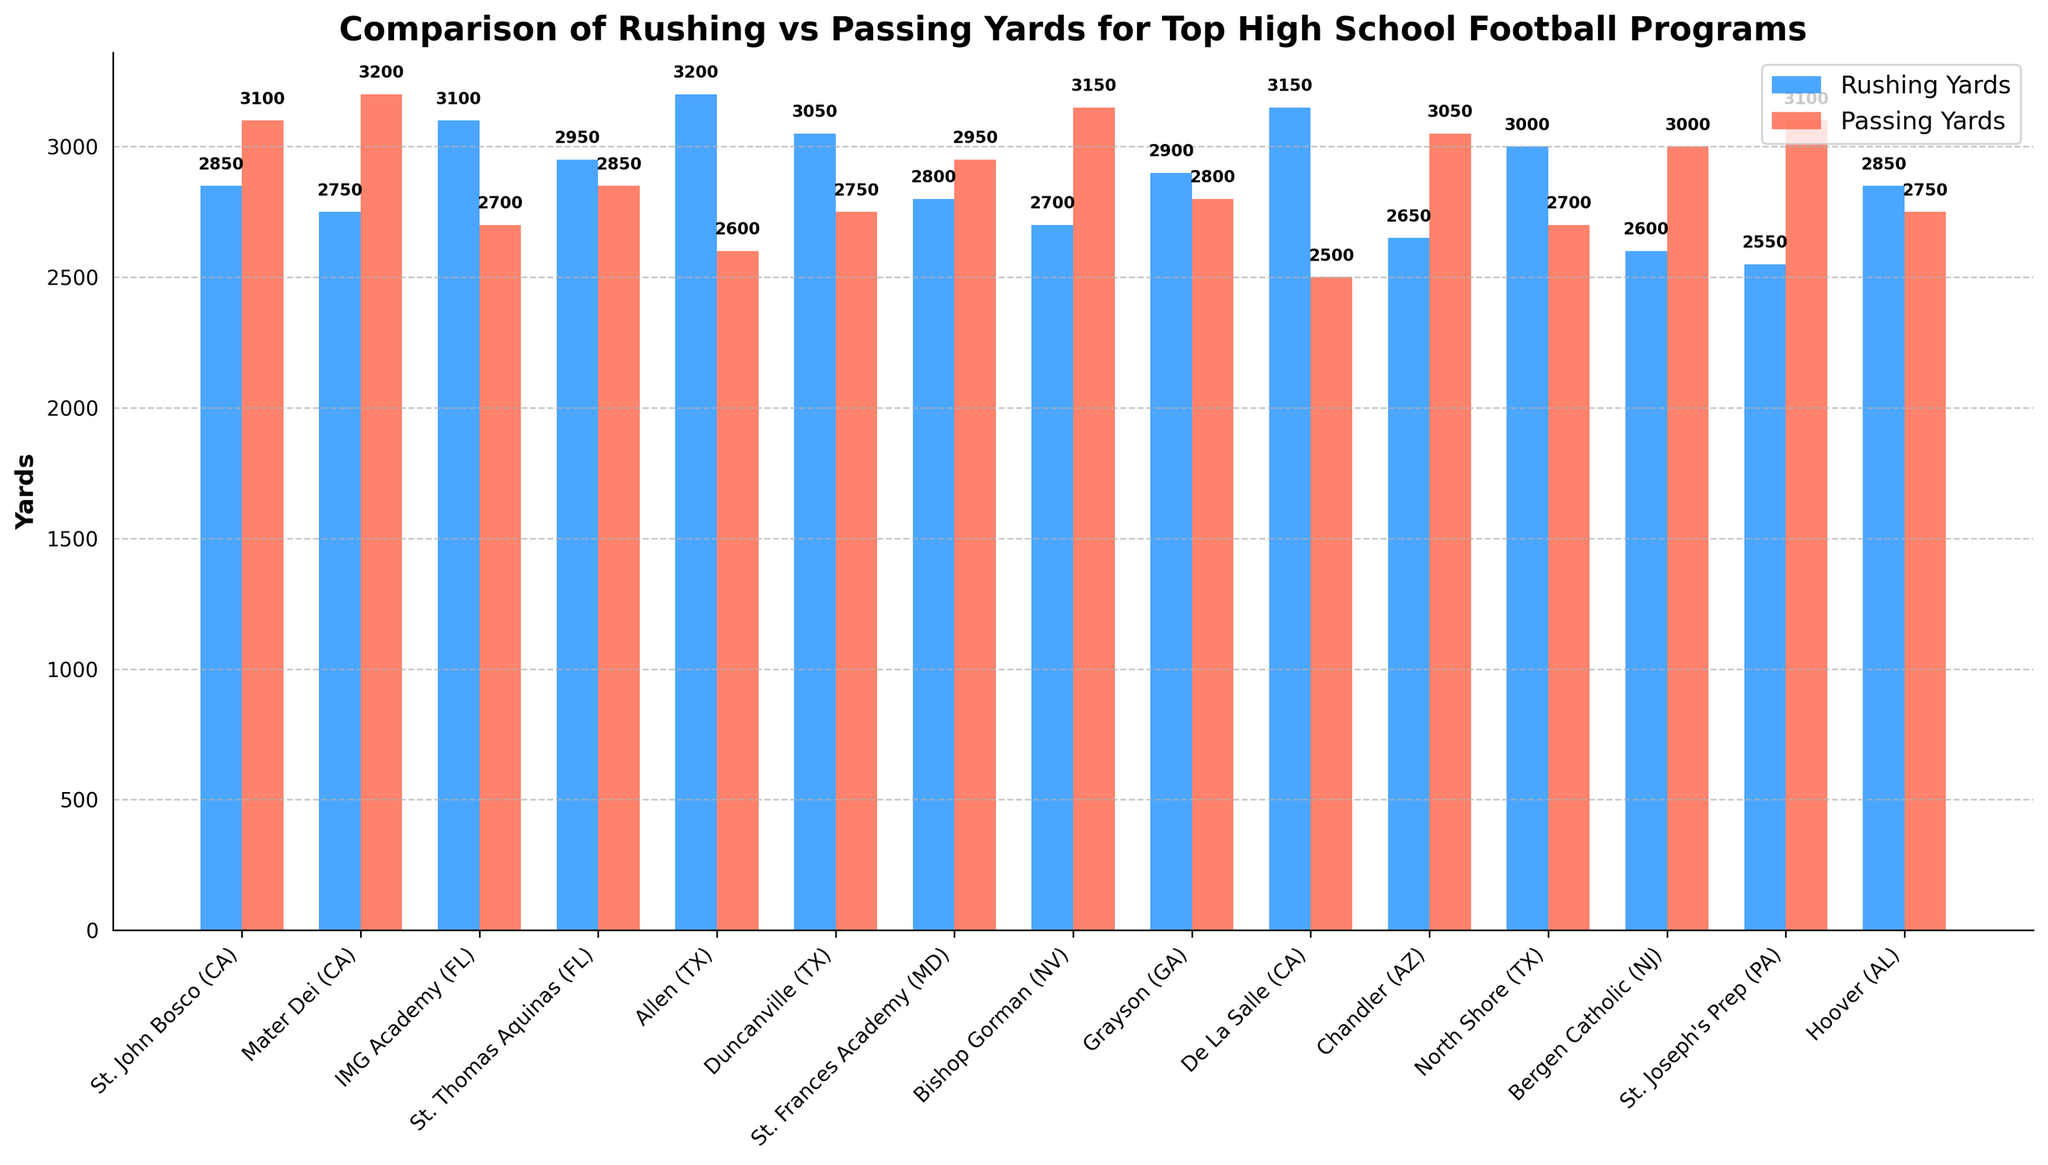Which school has the highest total yards gained by rushing? We need to look at the heights of the blue bars representing rushing yards. Allen (TX) has the highest blue bar with 3,200 yards.
Answer: Allen (TX) Which schools have more passing yards than rushing yards? We compare the height of red bars (passing yards) to blue bars (rushing yards) for each school. The schools are St. John Bosco (CA), Mater Dei (CA), Bishop Gorman (NV), Chandler (AZ), Bergen Catholic (NJ), and St. Joseph's Prep (PA).
Answer: St. John Bosco (CA), Mater Dei (CA), Bishop Gorman (NV), Chandler (AZ), Bergen Catholic (NJ), St. Joseph's Prep (PA) Which school has the smallest difference between rushing and passing yards? We calculate the absolute difference between rushing and passing yards for each school and find the smallest one. Grayson (GA) has a difference of 100 yards (2,900 - 2,800).
Answer: Grayson (GA) What is the total number of rushing yards for all the schools combined? We sum the heights of all blue bars. The total is 42,250 yards.
Answer: 42,250 yards Compare St. Thomas Aquinas (FL) and Hoover (AL), which one has more similarity in their rushing and passing yards? We compare the differences in rushing and passing yards for both schools. St. Thomas Aquinas (FL) has a 100-yard difference, while Hoover (AL) has a 100-yard difference. They both have the same difference, making them equally similar.
Answer: Both are equally similar Which school has a higher total yardage, IMG Academy (FL) or De La Salle (CA)? We calculate the sum of rushing and passing yards for both schools. IMG Academy (FL) has 5,800 yards (3,100+2,700), and De La Salle (CA) has 5,650 yards (3,150+2,500).
Answer: IMG Academy (FL) Which school has the second-lowest passing yards? We identify and rank the heights of the red bars. De La Salle (CA) has the lowest passing yards with 2,500, and Allen (TX) has the second-lowest with 2,600 yards.
Answer: Allen (TX) Which pair of schools has the highest combined yards (rushing + passing)? We calculate the total yards for each school and find the top two with the highest combined yards. St. John Bosco (CA) has 5,950 yards, and Mater Dei (CA) has 5,950 yards. The combined total is 11,900 yards.
Answer: St. John Bosco (CA) and Mater Dei (CA) Between Mater Dei (CA) and St. Joseph's Prep (PA), which school focuses more on passing than rushing? By comparing the height difference of the red and blue bars, we can determine the focus. Mater Dei (CA) has a passing yardage of 3,200 vs. 2,750 rushing, while St. Joseph's Prep (PA) has 3,100 vs. 2,550. Mater Dei (CA) has a larger difference (450 > 550).
Answer: St. Joseph's Prep (PA) Which school's total yardage (rushing + passing) is closest to the average total yardage of all schools? Calculate the total yardage for each school, the average of these total yardages, and compare the values. Total yardage sums are 3,850, 3,850,4,800, etc. Average yardage = 42,250+all other yards = sum/number of schools = 56150/15 schools = 3,743.6/md, Grayson (GA) with 5,700 yards is close to the average.
Answer: North Shore (TX) 